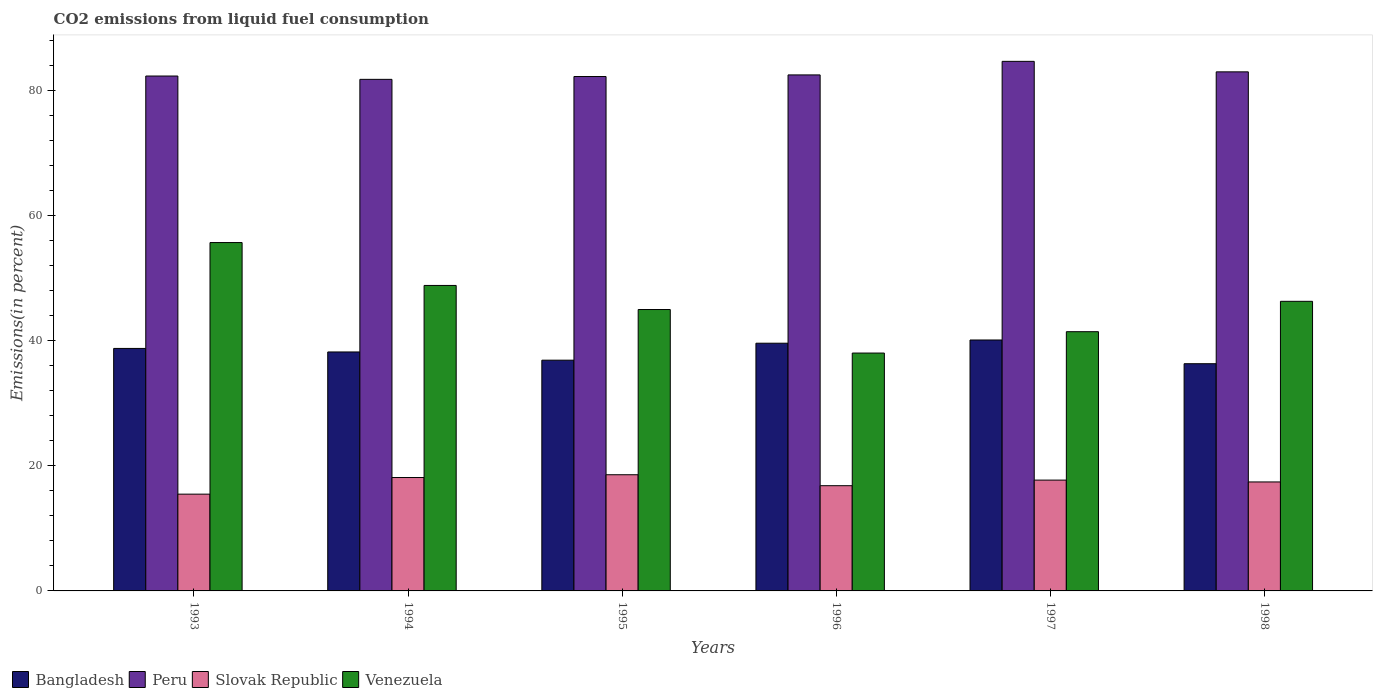Are the number of bars per tick equal to the number of legend labels?
Offer a very short reply. Yes. In how many cases, is the number of bars for a given year not equal to the number of legend labels?
Your answer should be compact. 0. What is the total CO2 emitted in Slovak Republic in 1994?
Ensure brevity in your answer.  18.13. Across all years, what is the maximum total CO2 emitted in Slovak Republic?
Offer a terse response. 18.58. Across all years, what is the minimum total CO2 emitted in Slovak Republic?
Provide a short and direct response. 15.48. In which year was the total CO2 emitted in Bangladesh minimum?
Your answer should be very brief. 1998. What is the total total CO2 emitted in Peru in the graph?
Offer a terse response. 496.66. What is the difference between the total CO2 emitted in Venezuela in 1994 and that in 1997?
Ensure brevity in your answer.  7.4. What is the difference between the total CO2 emitted in Peru in 1997 and the total CO2 emitted in Venezuela in 1996?
Give a very brief answer. 46.65. What is the average total CO2 emitted in Peru per year?
Ensure brevity in your answer.  82.78. In the year 1998, what is the difference between the total CO2 emitted in Venezuela and total CO2 emitted in Bangladesh?
Keep it short and to the point. 9.98. What is the ratio of the total CO2 emitted in Slovak Republic in 1996 to that in 1998?
Ensure brevity in your answer.  0.97. Is the total CO2 emitted in Venezuela in 1995 less than that in 1997?
Keep it short and to the point. No. What is the difference between the highest and the second highest total CO2 emitted in Venezuela?
Offer a terse response. 6.86. What is the difference between the highest and the lowest total CO2 emitted in Slovak Republic?
Provide a short and direct response. 3.1. In how many years, is the total CO2 emitted in Peru greater than the average total CO2 emitted in Peru taken over all years?
Your answer should be compact. 2. What does the 1st bar from the left in 1995 represents?
Keep it short and to the point. Bangladesh. What does the 1st bar from the right in 1995 represents?
Give a very brief answer. Venezuela. How many bars are there?
Your answer should be compact. 24. Are all the bars in the graph horizontal?
Your answer should be very brief. No. How many years are there in the graph?
Your response must be concise. 6. Are the values on the major ticks of Y-axis written in scientific E-notation?
Make the answer very short. No. Does the graph contain grids?
Your answer should be very brief. No. Where does the legend appear in the graph?
Provide a short and direct response. Bottom left. How are the legend labels stacked?
Keep it short and to the point. Horizontal. What is the title of the graph?
Your answer should be very brief. CO2 emissions from liquid fuel consumption. What is the label or title of the X-axis?
Give a very brief answer. Years. What is the label or title of the Y-axis?
Your answer should be compact. Emissions(in percent). What is the Emissions(in percent) of Bangladesh in 1993?
Your answer should be compact. 38.78. What is the Emissions(in percent) in Peru in 1993?
Your answer should be very brief. 82.35. What is the Emissions(in percent) of Slovak Republic in 1993?
Keep it short and to the point. 15.48. What is the Emissions(in percent) in Venezuela in 1993?
Provide a short and direct response. 55.71. What is the Emissions(in percent) in Bangladesh in 1994?
Your response must be concise. 38.22. What is the Emissions(in percent) of Peru in 1994?
Give a very brief answer. 81.82. What is the Emissions(in percent) in Slovak Republic in 1994?
Offer a terse response. 18.13. What is the Emissions(in percent) of Venezuela in 1994?
Make the answer very short. 48.85. What is the Emissions(in percent) in Bangladesh in 1995?
Your answer should be very brief. 36.9. What is the Emissions(in percent) in Peru in 1995?
Offer a very short reply. 82.27. What is the Emissions(in percent) of Slovak Republic in 1995?
Offer a terse response. 18.58. What is the Emissions(in percent) in Venezuela in 1995?
Your answer should be very brief. 45. What is the Emissions(in percent) of Bangladesh in 1996?
Give a very brief answer. 39.62. What is the Emissions(in percent) in Peru in 1996?
Provide a short and direct response. 82.53. What is the Emissions(in percent) in Slovak Republic in 1996?
Make the answer very short. 16.83. What is the Emissions(in percent) of Venezuela in 1996?
Your answer should be compact. 38.04. What is the Emissions(in percent) in Bangladesh in 1997?
Offer a terse response. 40.13. What is the Emissions(in percent) of Peru in 1997?
Ensure brevity in your answer.  84.69. What is the Emissions(in percent) of Slovak Republic in 1997?
Make the answer very short. 17.72. What is the Emissions(in percent) of Venezuela in 1997?
Your answer should be compact. 41.46. What is the Emissions(in percent) of Bangladesh in 1998?
Ensure brevity in your answer.  36.34. What is the Emissions(in percent) in Peru in 1998?
Provide a short and direct response. 83.01. What is the Emissions(in percent) in Slovak Republic in 1998?
Provide a succinct answer. 17.43. What is the Emissions(in percent) in Venezuela in 1998?
Your answer should be compact. 46.32. Across all years, what is the maximum Emissions(in percent) in Bangladesh?
Provide a succinct answer. 40.13. Across all years, what is the maximum Emissions(in percent) in Peru?
Offer a terse response. 84.69. Across all years, what is the maximum Emissions(in percent) in Slovak Republic?
Your response must be concise. 18.58. Across all years, what is the maximum Emissions(in percent) in Venezuela?
Give a very brief answer. 55.71. Across all years, what is the minimum Emissions(in percent) of Bangladesh?
Your answer should be compact. 36.34. Across all years, what is the minimum Emissions(in percent) of Peru?
Ensure brevity in your answer.  81.82. Across all years, what is the minimum Emissions(in percent) of Slovak Republic?
Provide a short and direct response. 15.48. Across all years, what is the minimum Emissions(in percent) in Venezuela?
Your answer should be compact. 38.04. What is the total Emissions(in percent) in Bangladesh in the graph?
Keep it short and to the point. 229.99. What is the total Emissions(in percent) of Peru in the graph?
Give a very brief answer. 496.66. What is the total Emissions(in percent) of Slovak Republic in the graph?
Give a very brief answer. 104.18. What is the total Emissions(in percent) in Venezuela in the graph?
Keep it short and to the point. 275.39. What is the difference between the Emissions(in percent) of Bangladesh in 1993 and that in 1994?
Offer a terse response. 0.56. What is the difference between the Emissions(in percent) of Peru in 1993 and that in 1994?
Your answer should be compact. 0.53. What is the difference between the Emissions(in percent) in Slovak Republic in 1993 and that in 1994?
Ensure brevity in your answer.  -2.66. What is the difference between the Emissions(in percent) of Venezuela in 1993 and that in 1994?
Give a very brief answer. 6.86. What is the difference between the Emissions(in percent) in Bangladesh in 1993 and that in 1995?
Make the answer very short. 1.88. What is the difference between the Emissions(in percent) of Peru in 1993 and that in 1995?
Make the answer very short. 0.08. What is the difference between the Emissions(in percent) of Slovak Republic in 1993 and that in 1995?
Provide a succinct answer. -3.1. What is the difference between the Emissions(in percent) of Venezuela in 1993 and that in 1995?
Offer a terse response. 10.71. What is the difference between the Emissions(in percent) of Bangladesh in 1993 and that in 1996?
Offer a terse response. -0.83. What is the difference between the Emissions(in percent) in Peru in 1993 and that in 1996?
Your answer should be compact. -0.18. What is the difference between the Emissions(in percent) in Slovak Republic in 1993 and that in 1996?
Your answer should be very brief. -1.35. What is the difference between the Emissions(in percent) of Venezuela in 1993 and that in 1996?
Provide a short and direct response. 17.67. What is the difference between the Emissions(in percent) of Bangladesh in 1993 and that in 1997?
Offer a very short reply. -1.35. What is the difference between the Emissions(in percent) in Peru in 1993 and that in 1997?
Your response must be concise. -2.35. What is the difference between the Emissions(in percent) of Slovak Republic in 1993 and that in 1997?
Provide a short and direct response. -2.25. What is the difference between the Emissions(in percent) of Venezuela in 1993 and that in 1997?
Offer a terse response. 14.26. What is the difference between the Emissions(in percent) of Bangladesh in 1993 and that in 1998?
Provide a succinct answer. 2.45. What is the difference between the Emissions(in percent) in Peru in 1993 and that in 1998?
Your answer should be compact. -0.67. What is the difference between the Emissions(in percent) of Slovak Republic in 1993 and that in 1998?
Provide a succinct answer. -1.95. What is the difference between the Emissions(in percent) in Venezuela in 1993 and that in 1998?
Provide a succinct answer. 9.4. What is the difference between the Emissions(in percent) in Bangladesh in 1994 and that in 1995?
Ensure brevity in your answer.  1.32. What is the difference between the Emissions(in percent) of Peru in 1994 and that in 1995?
Offer a terse response. -0.45. What is the difference between the Emissions(in percent) of Slovak Republic in 1994 and that in 1995?
Ensure brevity in your answer.  -0.45. What is the difference between the Emissions(in percent) in Venezuela in 1994 and that in 1995?
Provide a short and direct response. 3.85. What is the difference between the Emissions(in percent) of Bangladesh in 1994 and that in 1996?
Give a very brief answer. -1.4. What is the difference between the Emissions(in percent) of Peru in 1994 and that in 1996?
Give a very brief answer. -0.71. What is the difference between the Emissions(in percent) in Slovak Republic in 1994 and that in 1996?
Offer a terse response. 1.31. What is the difference between the Emissions(in percent) of Venezuela in 1994 and that in 1996?
Your answer should be compact. 10.81. What is the difference between the Emissions(in percent) of Bangladesh in 1994 and that in 1997?
Provide a succinct answer. -1.91. What is the difference between the Emissions(in percent) of Peru in 1994 and that in 1997?
Keep it short and to the point. -2.88. What is the difference between the Emissions(in percent) of Slovak Republic in 1994 and that in 1997?
Ensure brevity in your answer.  0.41. What is the difference between the Emissions(in percent) in Venezuela in 1994 and that in 1997?
Give a very brief answer. 7.4. What is the difference between the Emissions(in percent) in Bangladesh in 1994 and that in 1998?
Your response must be concise. 1.88. What is the difference between the Emissions(in percent) in Peru in 1994 and that in 1998?
Offer a very short reply. -1.2. What is the difference between the Emissions(in percent) in Slovak Republic in 1994 and that in 1998?
Offer a very short reply. 0.71. What is the difference between the Emissions(in percent) in Venezuela in 1994 and that in 1998?
Ensure brevity in your answer.  2.54. What is the difference between the Emissions(in percent) in Bangladesh in 1995 and that in 1996?
Make the answer very short. -2.71. What is the difference between the Emissions(in percent) in Peru in 1995 and that in 1996?
Your response must be concise. -0.26. What is the difference between the Emissions(in percent) in Slovak Republic in 1995 and that in 1996?
Provide a short and direct response. 1.75. What is the difference between the Emissions(in percent) of Venezuela in 1995 and that in 1996?
Your answer should be very brief. 6.96. What is the difference between the Emissions(in percent) in Bangladesh in 1995 and that in 1997?
Offer a terse response. -3.23. What is the difference between the Emissions(in percent) in Peru in 1995 and that in 1997?
Your answer should be very brief. -2.43. What is the difference between the Emissions(in percent) of Slovak Republic in 1995 and that in 1997?
Provide a short and direct response. 0.86. What is the difference between the Emissions(in percent) of Venezuela in 1995 and that in 1997?
Ensure brevity in your answer.  3.55. What is the difference between the Emissions(in percent) in Bangladesh in 1995 and that in 1998?
Provide a short and direct response. 0.56. What is the difference between the Emissions(in percent) in Peru in 1995 and that in 1998?
Give a very brief answer. -0.75. What is the difference between the Emissions(in percent) in Slovak Republic in 1995 and that in 1998?
Offer a terse response. 1.15. What is the difference between the Emissions(in percent) of Venezuela in 1995 and that in 1998?
Your response must be concise. -1.31. What is the difference between the Emissions(in percent) of Bangladesh in 1996 and that in 1997?
Your response must be concise. -0.52. What is the difference between the Emissions(in percent) of Peru in 1996 and that in 1997?
Make the answer very short. -2.17. What is the difference between the Emissions(in percent) in Slovak Republic in 1996 and that in 1997?
Make the answer very short. -0.89. What is the difference between the Emissions(in percent) of Venezuela in 1996 and that in 1997?
Your answer should be compact. -3.41. What is the difference between the Emissions(in percent) of Bangladesh in 1996 and that in 1998?
Give a very brief answer. 3.28. What is the difference between the Emissions(in percent) of Peru in 1996 and that in 1998?
Your answer should be very brief. -0.49. What is the difference between the Emissions(in percent) of Slovak Republic in 1996 and that in 1998?
Give a very brief answer. -0.6. What is the difference between the Emissions(in percent) of Venezuela in 1996 and that in 1998?
Give a very brief answer. -8.27. What is the difference between the Emissions(in percent) in Bangladesh in 1997 and that in 1998?
Your response must be concise. 3.79. What is the difference between the Emissions(in percent) in Peru in 1997 and that in 1998?
Your answer should be very brief. 1.68. What is the difference between the Emissions(in percent) of Slovak Republic in 1997 and that in 1998?
Keep it short and to the point. 0.29. What is the difference between the Emissions(in percent) in Venezuela in 1997 and that in 1998?
Give a very brief answer. -4.86. What is the difference between the Emissions(in percent) of Bangladesh in 1993 and the Emissions(in percent) of Peru in 1994?
Give a very brief answer. -43.03. What is the difference between the Emissions(in percent) of Bangladesh in 1993 and the Emissions(in percent) of Slovak Republic in 1994?
Keep it short and to the point. 20.65. What is the difference between the Emissions(in percent) in Bangladesh in 1993 and the Emissions(in percent) in Venezuela in 1994?
Give a very brief answer. -10.07. What is the difference between the Emissions(in percent) in Peru in 1993 and the Emissions(in percent) in Slovak Republic in 1994?
Provide a short and direct response. 64.21. What is the difference between the Emissions(in percent) in Peru in 1993 and the Emissions(in percent) in Venezuela in 1994?
Make the answer very short. 33.49. What is the difference between the Emissions(in percent) of Slovak Republic in 1993 and the Emissions(in percent) of Venezuela in 1994?
Keep it short and to the point. -33.38. What is the difference between the Emissions(in percent) of Bangladesh in 1993 and the Emissions(in percent) of Peru in 1995?
Keep it short and to the point. -43.48. What is the difference between the Emissions(in percent) in Bangladesh in 1993 and the Emissions(in percent) in Slovak Republic in 1995?
Your answer should be very brief. 20.2. What is the difference between the Emissions(in percent) in Bangladesh in 1993 and the Emissions(in percent) in Venezuela in 1995?
Your response must be concise. -6.22. What is the difference between the Emissions(in percent) in Peru in 1993 and the Emissions(in percent) in Slovak Republic in 1995?
Provide a succinct answer. 63.77. What is the difference between the Emissions(in percent) of Peru in 1993 and the Emissions(in percent) of Venezuela in 1995?
Ensure brevity in your answer.  37.34. What is the difference between the Emissions(in percent) of Slovak Republic in 1993 and the Emissions(in percent) of Venezuela in 1995?
Your answer should be very brief. -29.53. What is the difference between the Emissions(in percent) in Bangladesh in 1993 and the Emissions(in percent) in Peru in 1996?
Your answer should be compact. -43.74. What is the difference between the Emissions(in percent) in Bangladesh in 1993 and the Emissions(in percent) in Slovak Republic in 1996?
Provide a succinct answer. 21.95. What is the difference between the Emissions(in percent) of Bangladesh in 1993 and the Emissions(in percent) of Venezuela in 1996?
Your answer should be compact. 0.74. What is the difference between the Emissions(in percent) in Peru in 1993 and the Emissions(in percent) in Slovak Republic in 1996?
Keep it short and to the point. 65.52. What is the difference between the Emissions(in percent) of Peru in 1993 and the Emissions(in percent) of Venezuela in 1996?
Make the answer very short. 44.31. What is the difference between the Emissions(in percent) in Slovak Republic in 1993 and the Emissions(in percent) in Venezuela in 1996?
Provide a succinct answer. -22.56. What is the difference between the Emissions(in percent) in Bangladesh in 1993 and the Emissions(in percent) in Peru in 1997?
Provide a succinct answer. -45.91. What is the difference between the Emissions(in percent) in Bangladesh in 1993 and the Emissions(in percent) in Slovak Republic in 1997?
Your answer should be very brief. 21.06. What is the difference between the Emissions(in percent) in Bangladesh in 1993 and the Emissions(in percent) in Venezuela in 1997?
Give a very brief answer. -2.67. What is the difference between the Emissions(in percent) in Peru in 1993 and the Emissions(in percent) in Slovak Republic in 1997?
Provide a short and direct response. 64.62. What is the difference between the Emissions(in percent) in Peru in 1993 and the Emissions(in percent) in Venezuela in 1997?
Offer a very short reply. 40.89. What is the difference between the Emissions(in percent) in Slovak Republic in 1993 and the Emissions(in percent) in Venezuela in 1997?
Your answer should be compact. -25.98. What is the difference between the Emissions(in percent) in Bangladesh in 1993 and the Emissions(in percent) in Peru in 1998?
Provide a succinct answer. -44.23. What is the difference between the Emissions(in percent) of Bangladesh in 1993 and the Emissions(in percent) of Slovak Republic in 1998?
Your answer should be very brief. 21.35. What is the difference between the Emissions(in percent) in Bangladesh in 1993 and the Emissions(in percent) in Venezuela in 1998?
Provide a succinct answer. -7.53. What is the difference between the Emissions(in percent) of Peru in 1993 and the Emissions(in percent) of Slovak Republic in 1998?
Ensure brevity in your answer.  64.92. What is the difference between the Emissions(in percent) in Peru in 1993 and the Emissions(in percent) in Venezuela in 1998?
Your answer should be compact. 36.03. What is the difference between the Emissions(in percent) in Slovak Republic in 1993 and the Emissions(in percent) in Venezuela in 1998?
Your answer should be compact. -30.84. What is the difference between the Emissions(in percent) of Bangladesh in 1994 and the Emissions(in percent) of Peru in 1995?
Ensure brevity in your answer.  -44.05. What is the difference between the Emissions(in percent) of Bangladesh in 1994 and the Emissions(in percent) of Slovak Republic in 1995?
Offer a very short reply. 19.64. What is the difference between the Emissions(in percent) of Bangladesh in 1994 and the Emissions(in percent) of Venezuela in 1995?
Keep it short and to the point. -6.79. What is the difference between the Emissions(in percent) of Peru in 1994 and the Emissions(in percent) of Slovak Republic in 1995?
Provide a succinct answer. 63.23. What is the difference between the Emissions(in percent) of Peru in 1994 and the Emissions(in percent) of Venezuela in 1995?
Provide a short and direct response. 36.81. What is the difference between the Emissions(in percent) in Slovak Republic in 1994 and the Emissions(in percent) in Venezuela in 1995?
Offer a very short reply. -26.87. What is the difference between the Emissions(in percent) in Bangladesh in 1994 and the Emissions(in percent) in Peru in 1996?
Give a very brief answer. -44.31. What is the difference between the Emissions(in percent) in Bangladesh in 1994 and the Emissions(in percent) in Slovak Republic in 1996?
Make the answer very short. 21.39. What is the difference between the Emissions(in percent) in Bangladesh in 1994 and the Emissions(in percent) in Venezuela in 1996?
Offer a terse response. 0.18. What is the difference between the Emissions(in percent) in Peru in 1994 and the Emissions(in percent) in Slovak Republic in 1996?
Give a very brief answer. 64.99. What is the difference between the Emissions(in percent) of Peru in 1994 and the Emissions(in percent) of Venezuela in 1996?
Offer a terse response. 43.77. What is the difference between the Emissions(in percent) in Slovak Republic in 1994 and the Emissions(in percent) in Venezuela in 1996?
Make the answer very short. -19.91. What is the difference between the Emissions(in percent) in Bangladesh in 1994 and the Emissions(in percent) in Peru in 1997?
Your response must be concise. -46.48. What is the difference between the Emissions(in percent) in Bangladesh in 1994 and the Emissions(in percent) in Slovak Republic in 1997?
Offer a terse response. 20.49. What is the difference between the Emissions(in percent) in Bangladesh in 1994 and the Emissions(in percent) in Venezuela in 1997?
Your answer should be very brief. -3.24. What is the difference between the Emissions(in percent) of Peru in 1994 and the Emissions(in percent) of Slovak Republic in 1997?
Provide a short and direct response. 64.09. What is the difference between the Emissions(in percent) in Peru in 1994 and the Emissions(in percent) in Venezuela in 1997?
Ensure brevity in your answer.  40.36. What is the difference between the Emissions(in percent) in Slovak Republic in 1994 and the Emissions(in percent) in Venezuela in 1997?
Ensure brevity in your answer.  -23.32. What is the difference between the Emissions(in percent) of Bangladesh in 1994 and the Emissions(in percent) of Peru in 1998?
Provide a short and direct response. -44.8. What is the difference between the Emissions(in percent) of Bangladesh in 1994 and the Emissions(in percent) of Slovak Republic in 1998?
Your response must be concise. 20.79. What is the difference between the Emissions(in percent) of Bangladesh in 1994 and the Emissions(in percent) of Venezuela in 1998?
Keep it short and to the point. -8.1. What is the difference between the Emissions(in percent) in Peru in 1994 and the Emissions(in percent) in Slovak Republic in 1998?
Make the answer very short. 64.39. What is the difference between the Emissions(in percent) of Peru in 1994 and the Emissions(in percent) of Venezuela in 1998?
Make the answer very short. 35.5. What is the difference between the Emissions(in percent) in Slovak Republic in 1994 and the Emissions(in percent) in Venezuela in 1998?
Your answer should be compact. -28.18. What is the difference between the Emissions(in percent) of Bangladesh in 1995 and the Emissions(in percent) of Peru in 1996?
Ensure brevity in your answer.  -45.62. What is the difference between the Emissions(in percent) of Bangladesh in 1995 and the Emissions(in percent) of Slovak Republic in 1996?
Your answer should be compact. 20.07. What is the difference between the Emissions(in percent) of Bangladesh in 1995 and the Emissions(in percent) of Venezuela in 1996?
Your answer should be compact. -1.14. What is the difference between the Emissions(in percent) in Peru in 1995 and the Emissions(in percent) in Slovak Republic in 1996?
Make the answer very short. 65.44. What is the difference between the Emissions(in percent) in Peru in 1995 and the Emissions(in percent) in Venezuela in 1996?
Offer a very short reply. 44.22. What is the difference between the Emissions(in percent) of Slovak Republic in 1995 and the Emissions(in percent) of Venezuela in 1996?
Provide a succinct answer. -19.46. What is the difference between the Emissions(in percent) of Bangladesh in 1995 and the Emissions(in percent) of Peru in 1997?
Offer a terse response. -47.79. What is the difference between the Emissions(in percent) in Bangladesh in 1995 and the Emissions(in percent) in Slovak Republic in 1997?
Your response must be concise. 19.18. What is the difference between the Emissions(in percent) of Bangladesh in 1995 and the Emissions(in percent) of Venezuela in 1997?
Make the answer very short. -4.56. What is the difference between the Emissions(in percent) in Peru in 1995 and the Emissions(in percent) in Slovak Republic in 1997?
Keep it short and to the point. 64.54. What is the difference between the Emissions(in percent) in Peru in 1995 and the Emissions(in percent) in Venezuela in 1997?
Ensure brevity in your answer.  40.81. What is the difference between the Emissions(in percent) of Slovak Republic in 1995 and the Emissions(in percent) of Venezuela in 1997?
Your response must be concise. -22.88. What is the difference between the Emissions(in percent) in Bangladesh in 1995 and the Emissions(in percent) in Peru in 1998?
Ensure brevity in your answer.  -46.11. What is the difference between the Emissions(in percent) in Bangladesh in 1995 and the Emissions(in percent) in Slovak Republic in 1998?
Provide a short and direct response. 19.47. What is the difference between the Emissions(in percent) in Bangladesh in 1995 and the Emissions(in percent) in Venezuela in 1998?
Offer a very short reply. -9.41. What is the difference between the Emissions(in percent) of Peru in 1995 and the Emissions(in percent) of Slovak Republic in 1998?
Provide a short and direct response. 64.84. What is the difference between the Emissions(in percent) in Peru in 1995 and the Emissions(in percent) in Venezuela in 1998?
Keep it short and to the point. 35.95. What is the difference between the Emissions(in percent) in Slovak Republic in 1995 and the Emissions(in percent) in Venezuela in 1998?
Make the answer very short. -27.73. What is the difference between the Emissions(in percent) of Bangladesh in 1996 and the Emissions(in percent) of Peru in 1997?
Provide a succinct answer. -45.08. What is the difference between the Emissions(in percent) of Bangladesh in 1996 and the Emissions(in percent) of Slovak Republic in 1997?
Provide a succinct answer. 21.89. What is the difference between the Emissions(in percent) in Bangladesh in 1996 and the Emissions(in percent) in Venezuela in 1997?
Make the answer very short. -1.84. What is the difference between the Emissions(in percent) in Peru in 1996 and the Emissions(in percent) in Slovak Republic in 1997?
Keep it short and to the point. 64.8. What is the difference between the Emissions(in percent) in Peru in 1996 and the Emissions(in percent) in Venezuela in 1997?
Offer a very short reply. 41.07. What is the difference between the Emissions(in percent) in Slovak Republic in 1996 and the Emissions(in percent) in Venezuela in 1997?
Keep it short and to the point. -24.63. What is the difference between the Emissions(in percent) of Bangladesh in 1996 and the Emissions(in percent) of Peru in 1998?
Ensure brevity in your answer.  -43.4. What is the difference between the Emissions(in percent) in Bangladesh in 1996 and the Emissions(in percent) in Slovak Republic in 1998?
Give a very brief answer. 22.19. What is the difference between the Emissions(in percent) of Bangladesh in 1996 and the Emissions(in percent) of Venezuela in 1998?
Provide a succinct answer. -6.7. What is the difference between the Emissions(in percent) in Peru in 1996 and the Emissions(in percent) in Slovak Republic in 1998?
Your answer should be compact. 65.1. What is the difference between the Emissions(in percent) in Peru in 1996 and the Emissions(in percent) in Venezuela in 1998?
Make the answer very short. 36.21. What is the difference between the Emissions(in percent) in Slovak Republic in 1996 and the Emissions(in percent) in Venezuela in 1998?
Ensure brevity in your answer.  -29.49. What is the difference between the Emissions(in percent) of Bangladesh in 1997 and the Emissions(in percent) of Peru in 1998?
Provide a short and direct response. -42.88. What is the difference between the Emissions(in percent) in Bangladesh in 1997 and the Emissions(in percent) in Slovak Republic in 1998?
Offer a terse response. 22.7. What is the difference between the Emissions(in percent) in Bangladesh in 1997 and the Emissions(in percent) in Venezuela in 1998?
Offer a terse response. -6.18. What is the difference between the Emissions(in percent) in Peru in 1997 and the Emissions(in percent) in Slovak Republic in 1998?
Your answer should be compact. 67.26. What is the difference between the Emissions(in percent) in Peru in 1997 and the Emissions(in percent) in Venezuela in 1998?
Your answer should be very brief. 38.38. What is the difference between the Emissions(in percent) of Slovak Republic in 1997 and the Emissions(in percent) of Venezuela in 1998?
Your answer should be compact. -28.59. What is the average Emissions(in percent) of Bangladesh per year?
Keep it short and to the point. 38.33. What is the average Emissions(in percent) of Peru per year?
Your answer should be compact. 82.78. What is the average Emissions(in percent) in Slovak Republic per year?
Your answer should be very brief. 17.36. What is the average Emissions(in percent) of Venezuela per year?
Keep it short and to the point. 45.9. In the year 1993, what is the difference between the Emissions(in percent) in Bangladesh and Emissions(in percent) in Peru?
Ensure brevity in your answer.  -43.57. In the year 1993, what is the difference between the Emissions(in percent) of Bangladesh and Emissions(in percent) of Slovak Republic?
Make the answer very short. 23.3. In the year 1993, what is the difference between the Emissions(in percent) in Bangladesh and Emissions(in percent) in Venezuela?
Keep it short and to the point. -16.93. In the year 1993, what is the difference between the Emissions(in percent) of Peru and Emissions(in percent) of Slovak Republic?
Your response must be concise. 66.87. In the year 1993, what is the difference between the Emissions(in percent) of Peru and Emissions(in percent) of Venezuela?
Offer a very short reply. 26.63. In the year 1993, what is the difference between the Emissions(in percent) of Slovak Republic and Emissions(in percent) of Venezuela?
Your answer should be compact. -40.24. In the year 1994, what is the difference between the Emissions(in percent) of Bangladesh and Emissions(in percent) of Peru?
Provide a succinct answer. -43.6. In the year 1994, what is the difference between the Emissions(in percent) of Bangladesh and Emissions(in percent) of Slovak Republic?
Provide a short and direct response. 20.08. In the year 1994, what is the difference between the Emissions(in percent) of Bangladesh and Emissions(in percent) of Venezuela?
Provide a succinct answer. -10.64. In the year 1994, what is the difference between the Emissions(in percent) of Peru and Emissions(in percent) of Slovak Republic?
Ensure brevity in your answer.  63.68. In the year 1994, what is the difference between the Emissions(in percent) of Peru and Emissions(in percent) of Venezuela?
Your response must be concise. 32.96. In the year 1994, what is the difference between the Emissions(in percent) in Slovak Republic and Emissions(in percent) in Venezuela?
Your answer should be very brief. -30.72. In the year 1995, what is the difference between the Emissions(in percent) of Bangladesh and Emissions(in percent) of Peru?
Offer a terse response. -45.36. In the year 1995, what is the difference between the Emissions(in percent) of Bangladesh and Emissions(in percent) of Slovak Republic?
Make the answer very short. 18.32. In the year 1995, what is the difference between the Emissions(in percent) in Bangladesh and Emissions(in percent) in Venezuela?
Give a very brief answer. -8.1. In the year 1995, what is the difference between the Emissions(in percent) in Peru and Emissions(in percent) in Slovak Republic?
Your answer should be very brief. 63.69. In the year 1995, what is the difference between the Emissions(in percent) in Peru and Emissions(in percent) in Venezuela?
Give a very brief answer. 37.26. In the year 1995, what is the difference between the Emissions(in percent) of Slovak Republic and Emissions(in percent) of Venezuela?
Offer a very short reply. -26.42. In the year 1996, what is the difference between the Emissions(in percent) in Bangladesh and Emissions(in percent) in Peru?
Give a very brief answer. -42.91. In the year 1996, what is the difference between the Emissions(in percent) of Bangladesh and Emissions(in percent) of Slovak Republic?
Offer a terse response. 22.79. In the year 1996, what is the difference between the Emissions(in percent) of Bangladesh and Emissions(in percent) of Venezuela?
Provide a succinct answer. 1.57. In the year 1996, what is the difference between the Emissions(in percent) of Peru and Emissions(in percent) of Slovak Republic?
Offer a very short reply. 65.7. In the year 1996, what is the difference between the Emissions(in percent) of Peru and Emissions(in percent) of Venezuela?
Keep it short and to the point. 44.48. In the year 1996, what is the difference between the Emissions(in percent) in Slovak Republic and Emissions(in percent) in Venezuela?
Your answer should be compact. -21.21. In the year 1997, what is the difference between the Emissions(in percent) of Bangladesh and Emissions(in percent) of Peru?
Your response must be concise. -44.56. In the year 1997, what is the difference between the Emissions(in percent) in Bangladesh and Emissions(in percent) in Slovak Republic?
Provide a succinct answer. 22.41. In the year 1997, what is the difference between the Emissions(in percent) of Bangladesh and Emissions(in percent) of Venezuela?
Your response must be concise. -1.33. In the year 1997, what is the difference between the Emissions(in percent) in Peru and Emissions(in percent) in Slovak Republic?
Give a very brief answer. 66.97. In the year 1997, what is the difference between the Emissions(in percent) in Peru and Emissions(in percent) in Venezuela?
Your answer should be very brief. 43.24. In the year 1997, what is the difference between the Emissions(in percent) in Slovak Republic and Emissions(in percent) in Venezuela?
Your answer should be very brief. -23.73. In the year 1998, what is the difference between the Emissions(in percent) of Bangladesh and Emissions(in percent) of Peru?
Your response must be concise. -46.68. In the year 1998, what is the difference between the Emissions(in percent) of Bangladesh and Emissions(in percent) of Slovak Republic?
Provide a succinct answer. 18.91. In the year 1998, what is the difference between the Emissions(in percent) in Bangladesh and Emissions(in percent) in Venezuela?
Provide a succinct answer. -9.98. In the year 1998, what is the difference between the Emissions(in percent) in Peru and Emissions(in percent) in Slovak Republic?
Make the answer very short. 65.59. In the year 1998, what is the difference between the Emissions(in percent) of Peru and Emissions(in percent) of Venezuela?
Offer a terse response. 36.7. In the year 1998, what is the difference between the Emissions(in percent) in Slovak Republic and Emissions(in percent) in Venezuela?
Make the answer very short. -28.89. What is the ratio of the Emissions(in percent) of Bangladesh in 1993 to that in 1994?
Provide a succinct answer. 1.01. What is the ratio of the Emissions(in percent) of Peru in 1993 to that in 1994?
Your answer should be very brief. 1.01. What is the ratio of the Emissions(in percent) of Slovak Republic in 1993 to that in 1994?
Provide a succinct answer. 0.85. What is the ratio of the Emissions(in percent) of Venezuela in 1993 to that in 1994?
Your answer should be very brief. 1.14. What is the ratio of the Emissions(in percent) of Bangladesh in 1993 to that in 1995?
Offer a very short reply. 1.05. What is the ratio of the Emissions(in percent) of Peru in 1993 to that in 1995?
Your answer should be compact. 1. What is the ratio of the Emissions(in percent) in Slovak Republic in 1993 to that in 1995?
Your answer should be very brief. 0.83. What is the ratio of the Emissions(in percent) of Venezuela in 1993 to that in 1995?
Provide a succinct answer. 1.24. What is the ratio of the Emissions(in percent) in Bangladesh in 1993 to that in 1996?
Provide a succinct answer. 0.98. What is the ratio of the Emissions(in percent) of Slovak Republic in 1993 to that in 1996?
Your answer should be compact. 0.92. What is the ratio of the Emissions(in percent) of Venezuela in 1993 to that in 1996?
Make the answer very short. 1.46. What is the ratio of the Emissions(in percent) of Bangladesh in 1993 to that in 1997?
Give a very brief answer. 0.97. What is the ratio of the Emissions(in percent) in Peru in 1993 to that in 1997?
Offer a very short reply. 0.97. What is the ratio of the Emissions(in percent) of Slovak Republic in 1993 to that in 1997?
Provide a short and direct response. 0.87. What is the ratio of the Emissions(in percent) in Venezuela in 1993 to that in 1997?
Make the answer very short. 1.34. What is the ratio of the Emissions(in percent) of Bangladesh in 1993 to that in 1998?
Your answer should be compact. 1.07. What is the ratio of the Emissions(in percent) of Slovak Republic in 1993 to that in 1998?
Keep it short and to the point. 0.89. What is the ratio of the Emissions(in percent) in Venezuela in 1993 to that in 1998?
Your response must be concise. 1.2. What is the ratio of the Emissions(in percent) in Bangladesh in 1994 to that in 1995?
Give a very brief answer. 1.04. What is the ratio of the Emissions(in percent) in Venezuela in 1994 to that in 1995?
Make the answer very short. 1.09. What is the ratio of the Emissions(in percent) of Bangladesh in 1994 to that in 1996?
Provide a succinct answer. 0.96. What is the ratio of the Emissions(in percent) in Slovak Republic in 1994 to that in 1996?
Provide a short and direct response. 1.08. What is the ratio of the Emissions(in percent) of Venezuela in 1994 to that in 1996?
Your answer should be very brief. 1.28. What is the ratio of the Emissions(in percent) of Bangladesh in 1994 to that in 1997?
Keep it short and to the point. 0.95. What is the ratio of the Emissions(in percent) of Slovak Republic in 1994 to that in 1997?
Offer a terse response. 1.02. What is the ratio of the Emissions(in percent) of Venezuela in 1994 to that in 1997?
Your answer should be compact. 1.18. What is the ratio of the Emissions(in percent) of Bangladesh in 1994 to that in 1998?
Make the answer very short. 1.05. What is the ratio of the Emissions(in percent) of Peru in 1994 to that in 1998?
Your response must be concise. 0.99. What is the ratio of the Emissions(in percent) of Slovak Republic in 1994 to that in 1998?
Your answer should be very brief. 1.04. What is the ratio of the Emissions(in percent) of Venezuela in 1994 to that in 1998?
Offer a very short reply. 1.05. What is the ratio of the Emissions(in percent) of Bangladesh in 1995 to that in 1996?
Offer a terse response. 0.93. What is the ratio of the Emissions(in percent) in Slovak Republic in 1995 to that in 1996?
Your response must be concise. 1.1. What is the ratio of the Emissions(in percent) of Venezuela in 1995 to that in 1996?
Your answer should be compact. 1.18. What is the ratio of the Emissions(in percent) of Bangladesh in 1995 to that in 1997?
Your answer should be compact. 0.92. What is the ratio of the Emissions(in percent) of Peru in 1995 to that in 1997?
Offer a terse response. 0.97. What is the ratio of the Emissions(in percent) of Slovak Republic in 1995 to that in 1997?
Give a very brief answer. 1.05. What is the ratio of the Emissions(in percent) of Venezuela in 1995 to that in 1997?
Provide a succinct answer. 1.09. What is the ratio of the Emissions(in percent) in Bangladesh in 1995 to that in 1998?
Your answer should be compact. 1.02. What is the ratio of the Emissions(in percent) of Peru in 1995 to that in 1998?
Offer a terse response. 0.99. What is the ratio of the Emissions(in percent) in Slovak Republic in 1995 to that in 1998?
Your answer should be compact. 1.07. What is the ratio of the Emissions(in percent) in Venezuela in 1995 to that in 1998?
Make the answer very short. 0.97. What is the ratio of the Emissions(in percent) of Bangladesh in 1996 to that in 1997?
Offer a terse response. 0.99. What is the ratio of the Emissions(in percent) in Peru in 1996 to that in 1997?
Your answer should be very brief. 0.97. What is the ratio of the Emissions(in percent) of Slovak Republic in 1996 to that in 1997?
Your answer should be compact. 0.95. What is the ratio of the Emissions(in percent) in Venezuela in 1996 to that in 1997?
Offer a very short reply. 0.92. What is the ratio of the Emissions(in percent) in Bangladesh in 1996 to that in 1998?
Provide a short and direct response. 1.09. What is the ratio of the Emissions(in percent) in Peru in 1996 to that in 1998?
Keep it short and to the point. 0.99. What is the ratio of the Emissions(in percent) in Slovak Republic in 1996 to that in 1998?
Make the answer very short. 0.97. What is the ratio of the Emissions(in percent) of Venezuela in 1996 to that in 1998?
Your response must be concise. 0.82. What is the ratio of the Emissions(in percent) in Bangladesh in 1997 to that in 1998?
Provide a succinct answer. 1.1. What is the ratio of the Emissions(in percent) of Peru in 1997 to that in 1998?
Your answer should be compact. 1.02. What is the ratio of the Emissions(in percent) of Slovak Republic in 1997 to that in 1998?
Offer a very short reply. 1.02. What is the ratio of the Emissions(in percent) in Venezuela in 1997 to that in 1998?
Provide a short and direct response. 0.9. What is the difference between the highest and the second highest Emissions(in percent) in Bangladesh?
Keep it short and to the point. 0.52. What is the difference between the highest and the second highest Emissions(in percent) in Peru?
Your response must be concise. 1.68. What is the difference between the highest and the second highest Emissions(in percent) of Slovak Republic?
Give a very brief answer. 0.45. What is the difference between the highest and the second highest Emissions(in percent) of Venezuela?
Ensure brevity in your answer.  6.86. What is the difference between the highest and the lowest Emissions(in percent) of Bangladesh?
Your answer should be very brief. 3.79. What is the difference between the highest and the lowest Emissions(in percent) of Peru?
Your answer should be compact. 2.88. What is the difference between the highest and the lowest Emissions(in percent) in Slovak Republic?
Your answer should be compact. 3.1. What is the difference between the highest and the lowest Emissions(in percent) in Venezuela?
Offer a terse response. 17.67. 